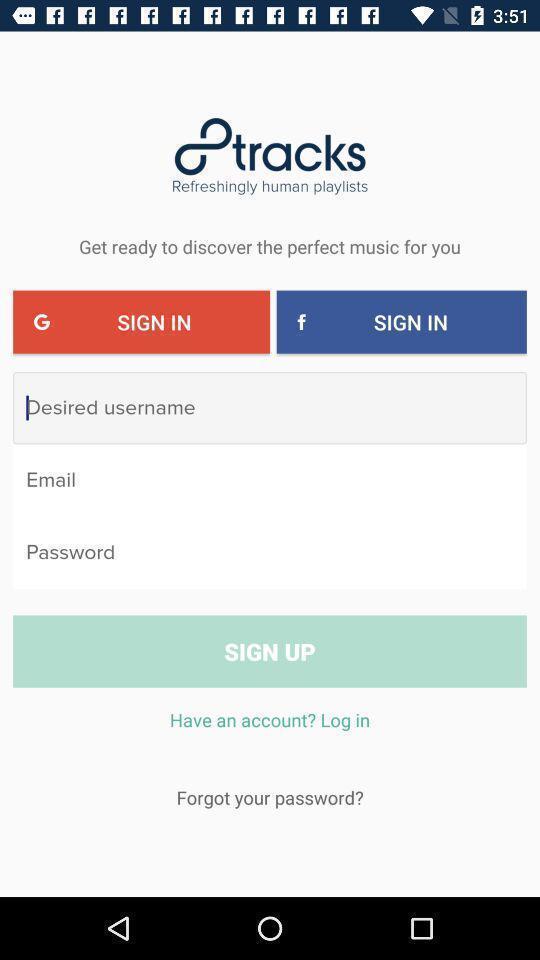Provide a description of this screenshot. Welcome page for a radio app. 